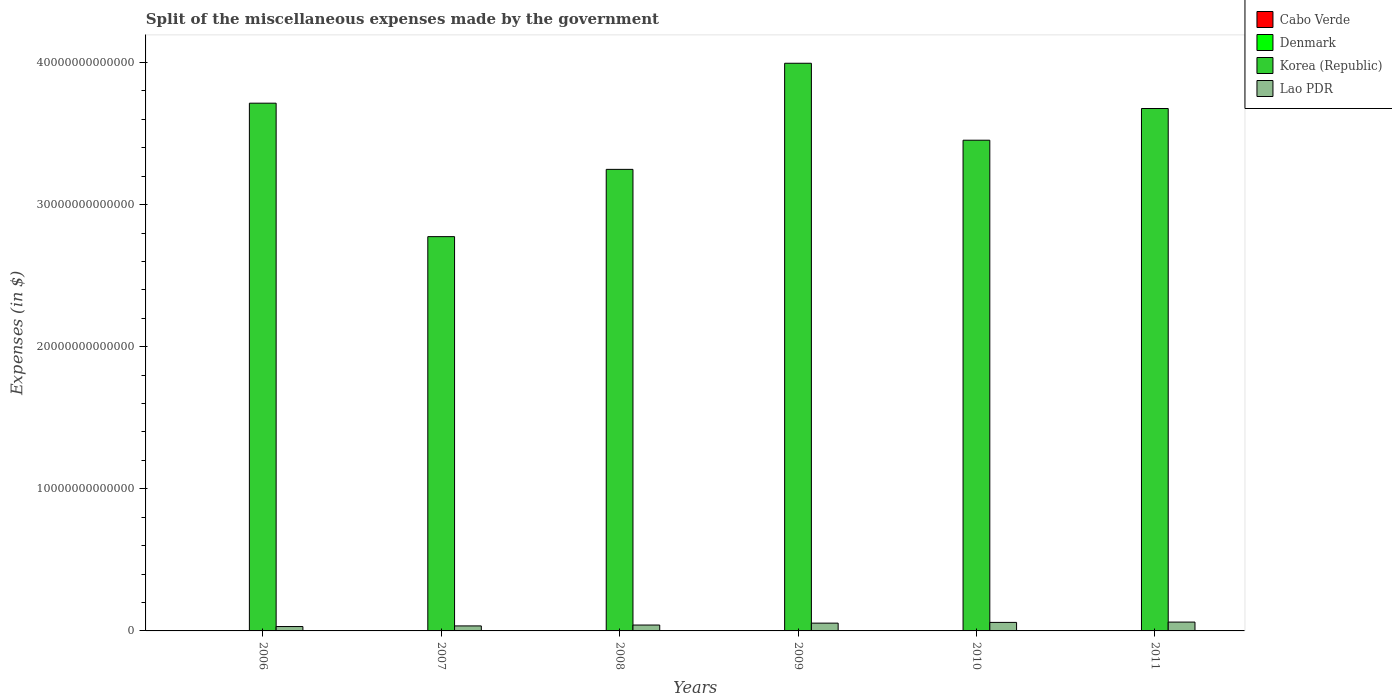How many groups of bars are there?
Offer a terse response. 6. How many bars are there on the 2nd tick from the left?
Your response must be concise. 4. How many bars are there on the 2nd tick from the right?
Your answer should be compact. 4. What is the miscellaneous expenses made by the government in Denmark in 2009?
Make the answer very short. 1.47e+1. Across all years, what is the maximum miscellaneous expenses made by the government in Korea (Republic)?
Your response must be concise. 3.99e+13. Across all years, what is the minimum miscellaneous expenses made by the government in Korea (Republic)?
Provide a succinct answer. 2.77e+13. In which year was the miscellaneous expenses made by the government in Denmark maximum?
Provide a succinct answer. 2007. In which year was the miscellaneous expenses made by the government in Denmark minimum?
Give a very brief answer. 2006. What is the total miscellaneous expenses made by the government in Korea (Republic) in the graph?
Your answer should be very brief. 2.09e+14. What is the difference between the miscellaneous expenses made by the government in Denmark in 2006 and that in 2009?
Offer a terse response. -1.11e+09. What is the difference between the miscellaneous expenses made by the government in Denmark in 2010 and the miscellaneous expenses made by the government in Korea (Republic) in 2006?
Your answer should be very brief. -3.71e+13. What is the average miscellaneous expenses made by the government in Lao PDR per year?
Your response must be concise. 4.74e+11. In the year 2011, what is the difference between the miscellaneous expenses made by the government in Denmark and miscellaneous expenses made by the government in Korea (Republic)?
Provide a succinct answer. -3.67e+13. What is the ratio of the miscellaneous expenses made by the government in Lao PDR in 2007 to that in 2008?
Keep it short and to the point. 0.85. Is the miscellaneous expenses made by the government in Cabo Verde in 2010 less than that in 2011?
Provide a short and direct response. Yes. What is the difference between the highest and the second highest miscellaneous expenses made by the government in Korea (Republic)?
Your response must be concise. 2.81e+12. What is the difference between the highest and the lowest miscellaneous expenses made by the government in Cabo Verde?
Provide a succinct answer. 1.32e+09. In how many years, is the miscellaneous expenses made by the government in Lao PDR greater than the average miscellaneous expenses made by the government in Lao PDR taken over all years?
Ensure brevity in your answer.  3. What does the 2nd bar from the left in 2011 represents?
Provide a succinct answer. Denmark. What does the 1st bar from the right in 2008 represents?
Provide a short and direct response. Lao PDR. How many bars are there?
Provide a succinct answer. 24. How many years are there in the graph?
Your response must be concise. 6. What is the difference between two consecutive major ticks on the Y-axis?
Offer a terse response. 1.00e+13. Are the values on the major ticks of Y-axis written in scientific E-notation?
Ensure brevity in your answer.  No. Does the graph contain any zero values?
Ensure brevity in your answer.  No. How many legend labels are there?
Ensure brevity in your answer.  4. What is the title of the graph?
Provide a short and direct response. Split of the miscellaneous expenses made by the government. What is the label or title of the Y-axis?
Ensure brevity in your answer.  Expenses (in $). What is the Expenses (in $) in Cabo Verde in 2006?
Make the answer very short. 1.05e+09. What is the Expenses (in $) in Denmark in 2006?
Make the answer very short. 1.36e+1. What is the Expenses (in $) in Korea (Republic) in 2006?
Your answer should be very brief. 3.71e+13. What is the Expenses (in $) of Lao PDR in 2006?
Offer a very short reply. 3.09e+11. What is the Expenses (in $) of Cabo Verde in 2007?
Offer a very short reply. 1.88e+09. What is the Expenses (in $) in Denmark in 2007?
Provide a succinct answer. 1.60e+1. What is the Expenses (in $) of Korea (Republic) in 2007?
Give a very brief answer. 2.77e+13. What is the Expenses (in $) in Lao PDR in 2007?
Make the answer very short. 3.52e+11. What is the Expenses (in $) of Cabo Verde in 2008?
Keep it short and to the point. 2.01e+09. What is the Expenses (in $) in Denmark in 2008?
Make the answer very short. 1.51e+1. What is the Expenses (in $) of Korea (Republic) in 2008?
Make the answer very short. 3.25e+13. What is the Expenses (in $) in Lao PDR in 2008?
Your answer should be very brief. 4.14e+11. What is the Expenses (in $) in Cabo Verde in 2009?
Your answer should be very brief. 6.89e+08. What is the Expenses (in $) of Denmark in 2009?
Provide a short and direct response. 1.47e+1. What is the Expenses (in $) in Korea (Republic) in 2009?
Keep it short and to the point. 3.99e+13. What is the Expenses (in $) of Lao PDR in 2009?
Your answer should be very brief. 5.48e+11. What is the Expenses (in $) of Cabo Verde in 2010?
Give a very brief answer. 1.46e+09. What is the Expenses (in $) of Denmark in 2010?
Your response must be concise. 1.55e+1. What is the Expenses (in $) in Korea (Republic) in 2010?
Provide a succinct answer. 3.45e+13. What is the Expenses (in $) of Lao PDR in 2010?
Provide a short and direct response. 6.00e+11. What is the Expenses (in $) in Cabo Verde in 2011?
Keep it short and to the point. 1.80e+09. What is the Expenses (in $) of Denmark in 2011?
Give a very brief answer. 1.57e+1. What is the Expenses (in $) in Korea (Republic) in 2011?
Provide a short and direct response. 3.68e+13. What is the Expenses (in $) in Lao PDR in 2011?
Your answer should be compact. 6.22e+11. Across all years, what is the maximum Expenses (in $) in Cabo Verde?
Provide a succinct answer. 2.01e+09. Across all years, what is the maximum Expenses (in $) of Denmark?
Provide a succinct answer. 1.60e+1. Across all years, what is the maximum Expenses (in $) in Korea (Republic)?
Make the answer very short. 3.99e+13. Across all years, what is the maximum Expenses (in $) of Lao PDR?
Your response must be concise. 6.22e+11. Across all years, what is the minimum Expenses (in $) in Cabo Verde?
Your answer should be very brief. 6.89e+08. Across all years, what is the minimum Expenses (in $) of Denmark?
Offer a terse response. 1.36e+1. Across all years, what is the minimum Expenses (in $) of Korea (Republic)?
Make the answer very short. 2.77e+13. Across all years, what is the minimum Expenses (in $) of Lao PDR?
Provide a short and direct response. 3.09e+11. What is the total Expenses (in $) of Cabo Verde in the graph?
Provide a short and direct response. 8.88e+09. What is the total Expenses (in $) of Denmark in the graph?
Your answer should be very brief. 9.06e+1. What is the total Expenses (in $) in Korea (Republic) in the graph?
Your response must be concise. 2.09e+14. What is the total Expenses (in $) in Lao PDR in the graph?
Keep it short and to the point. 2.85e+12. What is the difference between the Expenses (in $) in Cabo Verde in 2006 and that in 2007?
Provide a short and direct response. -8.30e+08. What is the difference between the Expenses (in $) of Denmark in 2006 and that in 2007?
Keep it short and to the point. -2.40e+09. What is the difference between the Expenses (in $) in Korea (Republic) in 2006 and that in 2007?
Your answer should be compact. 9.39e+12. What is the difference between the Expenses (in $) of Lao PDR in 2006 and that in 2007?
Your answer should be very brief. -4.33e+1. What is the difference between the Expenses (in $) of Cabo Verde in 2006 and that in 2008?
Your answer should be compact. -9.66e+08. What is the difference between the Expenses (in $) of Denmark in 2006 and that in 2008?
Provide a short and direct response. -1.54e+09. What is the difference between the Expenses (in $) of Korea (Republic) in 2006 and that in 2008?
Your answer should be very brief. 4.66e+12. What is the difference between the Expenses (in $) of Lao PDR in 2006 and that in 2008?
Your answer should be compact. -1.05e+11. What is the difference between the Expenses (in $) of Cabo Verde in 2006 and that in 2009?
Your response must be concise. 3.58e+08. What is the difference between the Expenses (in $) in Denmark in 2006 and that in 2009?
Your response must be concise. -1.11e+09. What is the difference between the Expenses (in $) of Korea (Republic) in 2006 and that in 2009?
Offer a very short reply. -2.81e+12. What is the difference between the Expenses (in $) in Lao PDR in 2006 and that in 2009?
Your answer should be very brief. -2.39e+11. What is the difference between the Expenses (in $) in Cabo Verde in 2006 and that in 2010?
Your response must be concise. -4.09e+08. What is the difference between the Expenses (in $) of Denmark in 2006 and that in 2010?
Offer a terse response. -1.90e+09. What is the difference between the Expenses (in $) in Korea (Republic) in 2006 and that in 2010?
Give a very brief answer. 2.61e+12. What is the difference between the Expenses (in $) of Lao PDR in 2006 and that in 2010?
Ensure brevity in your answer.  -2.91e+11. What is the difference between the Expenses (in $) of Cabo Verde in 2006 and that in 2011?
Give a very brief answer. -7.53e+08. What is the difference between the Expenses (in $) in Denmark in 2006 and that in 2011?
Offer a terse response. -2.07e+09. What is the difference between the Expenses (in $) in Korea (Republic) in 2006 and that in 2011?
Ensure brevity in your answer.  3.75e+11. What is the difference between the Expenses (in $) in Lao PDR in 2006 and that in 2011?
Your answer should be compact. -3.13e+11. What is the difference between the Expenses (in $) of Cabo Verde in 2007 and that in 2008?
Give a very brief answer. -1.36e+08. What is the difference between the Expenses (in $) in Denmark in 2007 and that in 2008?
Provide a succinct answer. 8.52e+08. What is the difference between the Expenses (in $) of Korea (Republic) in 2007 and that in 2008?
Your answer should be compact. -4.73e+12. What is the difference between the Expenses (in $) of Lao PDR in 2007 and that in 2008?
Make the answer very short. -6.17e+1. What is the difference between the Expenses (in $) in Cabo Verde in 2007 and that in 2009?
Ensure brevity in your answer.  1.19e+09. What is the difference between the Expenses (in $) of Denmark in 2007 and that in 2009?
Provide a short and direct response. 1.28e+09. What is the difference between the Expenses (in $) in Korea (Republic) in 2007 and that in 2009?
Your answer should be very brief. -1.22e+13. What is the difference between the Expenses (in $) of Lao PDR in 2007 and that in 2009?
Keep it short and to the point. -1.96e+11. What is the difference between the Expenses (in $) in Cabo Verde in 2007 and that in 2010?
Your answer should be very brief. 4.22e+08. What is the difference between the Expenses (in $) in Denmark in 2007 and that in 2010?
Ensure brevity in your answer.  4.92e+08. What is the difference between the Expenses (in $) of Korea (Republic) in 2007 and that in 2010?
Your answer should be compact. -6.79e+12. What is the difference between the Expenses (in $) in Lao PDR in 2007 and that in 2010?
Ensure brevity in your answer.  -2.48e+11. What is the difference between the Expenses (in $) in Cabo Verde in 2007 and that in 2011?
Give a very brief answer. 7.77e+07. What is the difference between the Expenses (in $) in Denmark in 2007 and that in 2011?
Make the answer very short. 3.27e+08. What is the difference between the Expenses (in $) in Korea (Republic) in 2007 and that in 2011?
Your response must be concise. -9.02e+12. What is the difference between the Expenses (in $) in Lao PDR in 2007 and that in 2011?
Give a very brief answer. -2.70e+11. What is the difference between the Expenses (in $) of Cabo Verde in 2008 and that in 2009?
Your response must be concise. 1.32e+09. What is the difference between the Expenses (in $) of Denmark in 2008 and that in 2009?
Offer a very short reply. 4.30e+08. What is the difference between the Expenses (in $) in Korea (Republic) in 2008 and that in 2009?
Provide a succinct answer. -7.47e+12. What is the difference between the Expenses (in $) of Lao PDR in 2008 and that in 2009?
Your response must be concise. -1.34e+11. What is the difference between the Expenses (in $) of Cabo Verde in 2008 and that in 2010?
Your response must be concise. 5.58e+08. What is the difference between the Expenses (in $) in Denmark in 2008 and that in 2010?
Make the answer very short. -3.60e+08. What is the difference between the Expenses (in $) in Korea (Republic) in 2008 and that in 2010?
Offer a very short reply. -2.05e+12. What is the difference between the Expenses (in $) in Lao PDR in 2008 and that in 2010?
Make the answer very short. -1.86e+11. What is the difference between the Expenses (in $) in Cabo Verde in 2008 and that in 2011?
Offer a terse response. 2.14e+08. What is the difference between the Expenses (in $) in Denmark in 2008 and that in 2011?
Offer a very short reply. -5.25e+08. What is the difference between the Expenses (in $) of Korea (Republic) in 2008 and that in 2011?
Ensure brevity in your answer.  -4.28e+12. What is the difference between the Expenses (in $) in Lao PDR in 2008 and that in 2011?
Your answer should be compact. -2.08e+11. What is the difference between the Expenses (in $) of Cabo Verde in 2009 and that in 2010?
Your response must be concise. -7.67e+08. What is the difference between the Expenses (in $) in Denmark in 2009 and that in 2010?
Offer a terse response. -7.90e+08. What is the difference between the Expenses (in $) of Korea (Republic) in 2009 and that in 2010?
Give a very brief answer. 5.41e+12. What is the difference between the Expenses (in $) in Lao PDR in 2009 and that in 2010?
Your answer should be compact. -5.21e+1. What is the difference between the Expenses (in $) in Cabo Verde in 2009 and that in 2011?
Ensure brevity in your answer.  -1.11e+09. What is the difference between the Expenses (in $) of Denmark in 2009 and that in 2011?
Provide a succinct answer. -9.55e+08. What is the difference between the Expenses (in $) in Korea (Republic) in 2009 and that in 2011?
Your answer should be very brief. 3.18e+12. What is the difference between the Expenses (in $) of Lao PDR in 2009 and that in 2011?
Your response must be concise. -7.41e+1. What is the difference between the Expenses (in $) in Cabo Verde in 2010 and that in 2011?
Your response must be concise. -3.44e+08. What is the difference between the Expenses (in $) in Denmark in 2010 and that in 2011?
Your answer should be very brief. -1.65e+08. What is the difference between the Expenses (in $) in Korea (Republic) in 2010 and that in 2011?
Your answer should be very brief. -2.23e+12. What is the difference between the Expenses (in $) in Lao PDR in 2010 and that in 2011?
Your response must be concise. -2.19e+1. What is the difference between the Expenses (in $) of Cabo Verde in 2006 and the Expenses (in $) of Denmark in 2007?
Your answer should be compact. -1.49e+1. What is the difference between the Expenses (in $) in Cabo Verde in 2006 and the Expenses (in $) in Korea (Republic) in 2007?
Provide a succinct answer. -2.77e+13. What is the difference between the Expenses (in $) of Cabo Verde in 2006 and the Expenses (in $) of Lao PDR in 2007?
Provide a succinct answer. -3.51e+11. What is the difference between the Expenses (in $) of Denmark in 2006 and the Expenses (in $) of Korea (Republic) in 2007?
Offer a terse response. -2.77e+13. What is the difference between the Expenses (in $) of Denmark in 2006 and the Expenses (in $) of Lao PDR in 2007?
Offer a terse response. -3.39e+11. What is the difference between the Expenses (in $) in Korea (Republic) in 2006 and the Expenses (in $) in Lao PDR in 2007?
Offer a terse response. 3.68e+13. What is the difference between the Expenses (in $) of Cabo Verde in 2006 and the Expenses (in $) of Denmark in 2008?
Offer a terse response. -1.41e+1. What is the difference between the Expenses (in $) of Cabo Verde in 2006 and the Expenses (in $) of Korea (Republic) in 2008?
Ensure brevity in your answer.  -3.25e+13. What is the difference between the Expenses (in $) in Cabo Verde in 2006 and the Expenses (in $) in Lao PDR in 2008?
Provide a short and direct response. -4.13e+11. What is the difference between the Expenses (in $) in Denmark in 2006 and the Expenses (in $) in Korea (Republic) in 2008?
Your response must be concise. -3.25e+13. What is the difference between the Expenses (in $) of Denmark in 2006 and the Expenses (in $) of Lao PDR in 2008?
Provide a succinct answer. -4.00e+11. What is the difference between the Expenses (in $) in Korea (Republic) in 2006 and the Expenses (in $) in Lao PDR in 2008?
Provide a succinct answer. 3.67e+13. What is the difference between the Expenses (in $) in Cabo Verde in 2006 and the Expenses (in $) in Denmark in 2009?
Offer a terse response. -1.37e+1. What is the difference between the Expenses (in $) in Cabo Verde in 2006 and the Expenses (in $) in Korea (Republic) in 2009?
Your response must be concise. -3.99e+13. What is the difference between the Expenses (in $) in Cabo Verde in 2006 and the Expenses (in $) in Lao PDR in 2009?
Ensure brevity in your answer.  -5.47e+11. What is the difference between the Expenses (in $) of Denmark in 2006 and the Expenses (in $) of Korea (Republic) in 2009?
Ensure brevity in your answer.  -3.99e+13. What is the difference between the Expenses (in $) of Denmark in 2006 and the Expenses (in $) of Lao PDR in 2009?
Provide a short and direct response. -5.34e+11. What is the difference between the Expenses (in $) in Korea (Republic) in 2006 and the Expenses (in $) in Lao PDR in 2009?
Your answer should be very brief. 3.66e+13. What is the difference between the Expenses (in $) in Cabo Verde in 2006 and the Expenses (in $) in Denmark in 2010?
Give a very brief answer. -1.45e+1. What is the difference between the Expenses (in $) in Cabo Verde in 2006 and the Expenses (in $) in Korea (Republic) in 2010?
Offer a terse response. -3.45e+13. What is the difference between the Expenses (in $) of Cabo Verde in 2006 and the Expenses (in $) of Lao PDR in 2010?
Offer a very short reply. -5.99e+11. What is the difference between the Expenses (in $) of Denmark in 2006 and the Expenses (in $) of Korea (Republic) in 2010?
Give a very brief answer. -3.45e+13. What is the difference between the Expenses (in $) of Denmark in 2006 and the Expenses (in $) of Lao PDR in 2010?
Keep it short and to the point. -5.87e+11. What is the difference between the Expenses (in $) in Korea (Republic) in 2006 and the Expenses (in $) in Lao PDR in 2010?
Ensure brevity in your answer.  3.65e+13. What is the difference between the Expenses (in $) in Cabo Verde in 2006 and the Expenses (in $) in Denmark in 2011?
Offer a terse response. -1.46e+1. What is the difference between the Expenses (in $) in Cabo Verde in 2006 and the Expenses (in $) in Korea (Republic) in 2011?
Ensure brevity in your answer.  -3.68e+13. What is the difference between the Expenses (in $) in Cabo Verde in 2006 and the Expenses (in $) in Lao PDR in 2011?
Your response must be concise. -6.21e+11. What is the difference between the Expenses (in $) of Denmark in 2006 and the Expenses (in $) of Korea (Republic) in 2011?
Keep it short and to the point. -3.67e+13. What is the difference between the Expenses (in $) in Denmark in 2006 and the Expenses (in $) in Lao PDR in 2011?
Offer a very short reply. -6.09e+11. What is the difference between the Expenses (in $) of Korea (Republic) in 2006 and the Expenses (in $) of Lao PDR in 2011?
Your answer should be compact. 3.65e+13. What is the difference between the Expenses (in $) in Cabo Verde in 2007 and the Expenses (in $) in Denmark in 2008?
Keep it short and to the point. -1.33e+1. What is the difference between the Expenses (in $) of Cabo Verde in 2007 and the Expenses (in $) of Korea (Republic) in 2008?
Offer a terse response. -3.25e+13. What is the difference between the Expenses (in $) in Cabo Verde in 2007 and the Expenses (in $) in Lao PDR in 2008?
Keep it short and to the point. -4.12e+11. What is the difference between the Expenses (in $) in Denmark in 2007 and the Expenses (in $) in Korea (Republic) in 2008?
Make the answer very short. -3.25e+13. What is the difference between the Expenses (in $) of Denmark in 2007 and the Expenses (in $) of Lao PDR in 2008?
Ensure brevity in your answer.  -3.98e+11. What is the difference between the Expenses (in $) in Korea (Republic) in 2007 and the Expenses (in $) in Lao PDR in 2008?
Ensure brevity in your answer.  2.73e+13. What is the difference between the Expenses (in $) in Cabo Verde in 2007 and the Expenses (in $) in Denmark in 2009?
Provide a succinct answer. -1.28e+1. What is the difference between the Expenses (in $) of Cabo Verde in 2007 and the Expenses (in $) of Korea (Republic) in 2009?
Offer a very short reply. -3.99e+13. What is the difference between the Expenses (in $) in Cabo Verde in 2007 and the Expenses (in $) in Lao PDR in 2009?
Provide a succinct answer. -5.46e+11. What is the difference between the Expenses (in $) in Denmark in 2007 and the Expenses (in $) in Korea (Republic) in 2009?
Offer a terse response. -3.99e+13. What is the difference between the Expenses (in $) in Denmark in 2007 and the Expenses (in $) in Lao PDR in 2009?
Provide a short and direct response. -5.32e+11. What is the difference between the Expenses (in $) of Korea (Republic) in 2007 and the Expenses (in $) of Lao PDR in 2009?
Make the answer very short. 2.72e+13. What is the difference between the Expenses (in $) in Cabo Verde in 2007 and the Expenses (in $) in Denmark in 2010?
Offer a very short reply. -1.36e+1. What is the difference between the Expenses (in $) in Cabo Verde in 2007 and the Expenses (in $) in Korea (Republic) in 2010?
Your response must be concise. -3.45e+13. What is the difference between the Expenses (in $) of Cabo Verde in 2007 and the Expenses (in $) of Lao PDR in 2010?
Your answer should be very brief. -5.98e+11. What is the difference between the Expenses (in $) in Denmark in 2007 and the Expenses (in $) in Korea (Republic) in 2010?
Your answer should be very brief. -3.45e+13. What is the difference between the Expenses (in $) of Denmark in 2007 and the Expenses (in $) of Lao PDR in 2010?
Keep it short and to the point. -5.84e+11. What is the difference between the Expenses (in $) of Korea (Republic) in 2007 and the Expenses (in $) of Lao PDR in 2010?
Provide a succinct answer. 2.71e+13. What is the difference between the Expenses (in $) of Cabo Verde in 2007 and the Expenses (in $) of Denmark in 2011?
Your answer should be compact. -1.38e+1. What is the difference between the Expenses (in $) of Cabo Verde in 2007 and the Expenses (in $) of Korea (Republic) in 2011?
Provide a short and direct response. -3.68e+13. What is the difference between the Expenses (in $) of Cabo Verde in 2007 and the Expenses (in $) of Lao PDR in 2011?
Provide a succinct answer. -6.20e+11. What is the difference between the Expenses (in $) in Denmark in 2007 and the Expenses (in $) in Korea (Republic) in 2011?
Give a very brief answer. -3.67e+13. What is the difference between the Expenses (in $) of Denmark in 2007 and the Expenses (in $) of Lao PDR in 2011?
Your response must be concise. -6.06e+11. What is the difference between the Expenses (in $) of Korea (Republic) in 2007 and the Expenses (in $) of Lao PDR in 2011?
Give a very brief answer. 2.71e+13. What is the difference between the Expenses (in $) of Cabo Verde in 2008 and the Expenses (in $) of Denmark in 2009?
Ensure brevity in your answer.  -1.27e+1. What is the difference between the Expenses (in $) in Cabo Verde in 2008 and the Expenses (in $) in Korea (Republic) in 2009?
Your response must be concise. -3.99e+13. What is the difference between the Expenses (in $) in Cabo Verde in 2008 and the Expenses (in $) in Lao PDR in 2009?
Your answer should be compact. -5.46e+11. What is the difference between the Expenses (in $) of Denmark in 2008 and the Expenses (in $) of Korea (Republic) in 2009?
Provide a succinct answer. -3.99e+13. What is the difference between the Expenses (in $) in Denmark in 2008 and the Expenses (in $) in Lao PDR in 2009?
Your response must be concise. -5.33e+11. What is the difference between the Expenses (in $) of Korea (Republic) in 2008 and the Expenses (in $) of Lao PDR in 2009?
Your answer should be very brief. 3.19e+13. What is the difference between the Expenses (in $) in Cabo Verde in 2008 and the Expenses (in $) in Denmark in 2010?
Your answer should be very brief. -1.35e+1. What is the difference between the Expenses (in $) in Cabo Verde in 2008 and the Expenses (in $) in Korea (Republic) in 2010?
Keep it short and to the point. -3.45e+13. What is the difference between the Expenses (in $) of Cabo Verde in 2008 and the Expenses (in $) of Lao PDR in 2010?
Your answer should be compact. -5.98e+11. What is the difference between the Expenses (in $) in Denmark in 2008 and the Expenses (in $) in Korea (Republic) in 2010?
Give a very brief answer. -3.45e+13. What is the difference between the Expenses (in $) in Denmark in 2008 and the Expenses (in $) in Lao PDR in 2010?
Provide a succinct answer. -5.85e+11. What is the difference between the Expenses (in $) of Korea (Republic) in 2008 and the Expenses (in $) of Lao PDR in 2010?
Provide a short and direct response. 3.19e+13. What is the difference between the Expenses (in $) in Cabo Verde in 2008 and the Expenses (in $) in Denmark in 2011?
Give a very brief answer. -1.37e+1. What is the difference between the Expenses (in $) of Cabo Verde in 2008 and the Expenses (in $) of Korea (Republic) in 2011?
Make the answer very short. -3.68e+13. What is the difference between the Expenses (in $) of Cabo Verde in 2008 and the Expenses (in $) of Lao PDR in 2011?
Your response must be concise. -6.20e+11. What is the difference between the Expenses (in $) in Denmark in 2008 and the Expenses (in $) in Korea (Republic) in 2011?
Provide a short and direct response. -3.67e+13. What is the difference between the Expenses (in $) of Denmark in 2008 and the Expenses (in $) of Lao PDR in 2011?
Your response must be concise. -6.07e+11. What is the difference between the Expenses (in $) in Korea (Republic) in 2008 and the Expenses (in $) in Lao PDR in 2011?
Give a very brief answer. 3.19e+13. What is the difference between the Expenses (in $) of Cabo Verde in 2009 and the Expenses (in $) of Denmark in 2010?
Your response must be concise. -1.48e+1. What is the difference between the Expenses (in $) in Cabo Verde in 2009 and the Expenses (in $) in Korea (Republic) in 2010?
Give a very brief answer. -3.45e+13. What is the difference between the Expenses (in $) in Cabo Verde in 2009 and the Expenses (in $) in Lao PDR in 2010?
Your answer should be compact. -6.00e+11. What is the difference between the Expenses (in $) of Denmark in 2009 and the Expenses (in $) of Korea (Republic) in 2010?
Keep it short and to the point. -3.45e+13. What is the difference between the Expenses (in $) in Denmark in 2009 and the Expenses (in $) in Lao PDR in 2010?
Provide a short and direct response. -5.85e+11. What is the difference between the Expenses (in $) of Korea (Republic) in 2009 and the Expenses (in $) of Lao PDR in 2010?
Provide a short and direct response. 3.93e+13. What is the difference between the Expenses (in $) of Cabo Verde in 2009 and the Expenses (in $) of Denmark in 2011?
Offer a very short reply. -1.50e+1. What is the difference between the Expenses (in $) of Cabo Verde in 2009 and the Expenses (in $) of Korea (Republic) in 2011?
Your response must be concise. -3.68e+13. What is the difference between the Expenses (in $) of Cabo Verde in 2009 and the Expenses (in $) of Lao PDR in 2011?
Give a very brief answer. -6.21e+11. What is the difference between the Expenses (in $) in Denmark in 2009 and the Expenses (in $) in Korea (Republic) in 2011?
Ensure brevity in your answer.  -3.67e+13. What is the difference between the Expenses (in $) of Denmark in 2009 and the Expenses (in $) of Lao PDR in 2011?
Provide a short and direct response. -6.07e+11. What is the difference between the Expenses (in $) in Korea (Republic) in 2009 and the Expenses (in $) in Lao PDR in 2011?
Offer a very short reply. 3.93e+13. What is the difference between the Expenses (in $) in Cabo Verde in 2010 and the Expenses (in $) in Denmark in 2011?
Make the answer very short. -1.42e+1. What is the difference between the Expenses (in $) in Cabo Verde in 2010 and the Expenses (in $) in Korea (Republic) in 2011?
Offer a very short reply. -3.68e+13. What is the difference between the Expenses (in $) in Cabo Verde in 2010 and the Expenses (in $) in Lao PDR in 2011?
Ensure brevity in your answer.  -6.21e+11. What is the difference between the Expenses (in $) in Denmark in 2010 and the Expenses (in $) in Korea (Republic) in 2011?
Give a very brief answer. -3.67e+13. What is the difference between the Expenses (in $) of Denmark in 2010 and the Expenses (in $) of Lao PDR in 2011?
Your answer should be very brief. -6.07e+11. What is the difference between the Expenses (in $) of Korea (Republic) in 2010 and the Expenses (in $) of Lao PDR in 2011?
Your answer should be very brief. 3.39e+13. What is the average Expenses (in $) of Cabo Verde per year?
Keep it short and to the point. 1.48e+09. What is the average Expenses (in $) of Denmark per year?
Your answer should be very brief. 1.51e+1. What is the average Expenses (in $) in Korea (Republic) per year?
Provide a succinct answer. 3.48e+13. What is the average Expenses (in $) of Lao PDR per year?
Make the answer very short. 4.74e+11. In the year 2006, what is the difference between the Expenses (in $) of Cabo Verde and Expenses (in $) of Denmark?
Your answer should be very brief. -1.25e+1. In the year 2006, what is the difference between the Expenses (in $) in Cabo Verde and Expenses (in $) in Korea (Republic)?
Offer a very short reply. -3.71e+13. In the year 2006, what is the difference between the Expenses (in $) of Cabo Verde and Expenses (in $) of Lao PDR?
Keep it short and to the point. -3.08e+11. In the year 2006, what is the difference between the Expenses (in $) in Denmark and Expenses (in $) in Korea (Republic)?
Offer a terse response. -3.71e+13. In the year 2006, what is the difference between the Expenses (in $) of Denmark and Expenses (in $) of Lao PDR?
Make the answer very short. -2.95e+11. In the year 2006, what is the difference between the Expenses (in $) of Korea (Republic) and Expenses (in $) of Lao PDR?
Your response must be concise. 3.68e+13. In the year 2007, what is the difference between the Expenses (in $) of Cabo Verde and Expenses (in $) of Denmark?
Give a very brief answer. -1.41e+1. In the year 2007, what is the difference between the Expenses (in $) of Cabo Verde and Expenses (in $) of Korea (Republic)?
Your answer should be compact. -2.77e+13. In the year 2007, what is the difference between the Expenses (in $) in Cabo Verde and Expenses (in $) in Lao PDR?
Make the answer very short. -3.50e+11. In the year 2007, what is the difference between the Expenses (in $) in Denmark and Expenses (in $) in Korea (Republic)?
Provide a short and direct response. -2.77e+13. In the year 2007, what is the difference between the Expenses (in $) of Denmark and Expenses (in $) of Lao PDR?
Keep it short and to the point. -3.36e+11. In the year 2007, what is the difference between the Expenses (in $) of Korea (Republic) and Expenses (in $) of Lao PDR?
Your answer should be very brief. 2.74e+13. In the year 2008, what is the difference between the Expenses (in $) of Cabo Verde and Expenses (in $) of Denmark?
Offer a very short reply. -1.31e+1. In the year 2008, what is the difference between the Expenses (in $) in Cabo Verde and Expenses (in $) in Korea (Republic)?
Your answer should be very brief. -3.25e+13. In the year 2008, what is the difference between the Expenses (in $) of Cabo Verde and Expenses (in $) of Lao PDR?
Offer a very short reply. -4.12e+11. In the year 2008, what is the difference between the Expenses (in $) in Denmark and Expenses (in $) in Korea (Republic)?
Your response must be concise. -3.25e+13. In the year 2008, what is the difference between the Expenses (in $) in Denmark and Expenses (in $) in Lao PDR?
Provide a short and direct response. -3.99e+11. In the year 2008, what is the difference between the Expenses (in $) in Korea (Republic) and Expenses (in $) in Lao PDR?
Your answer should be very brief. 3.21e+13. In the year 2009, what is the difference between the Expenses (in $) of Cabo Verde and Expenses (in $) of Denmark?
Give a very brief answer. -1.40e+1. In the year 2009, what is the difference between the Expenses (in $) of Cabo Verde and Expenses (in $) of Korea (Republic)?
Offer a very short reply. -3.99e+13. In the year 2009, what is the difference between the Expenses (in $) of Cabo Verde and Expenses (in $) of Lao PDR?
Provide a short and direct response. -5.47e+11. In the year 2009, what is the difference between the Expenses (in $) of Denmark and Expenses (in $) of Korea (Republic)?
Provide a succinct answer. -3.99e+13. In the year 2009, what is the difference between the Expenses (in $) in Denmark and Expenses (in $) in Lao PDR?
Your answer should be very brief. -5.33e+11. In the year 2009, what is the difference between the Expenses (in $) in Korea (Republic) and Expenses (in $) in Lao PDR?
Your answer should be compact. 3.94e+13. In the year 2010, what is the difference between the Expenses (in $) of Cabo Verde and Expenses (in $) of Denmark?
Keep it short and to the point. -1.40e+1. In the year 2010, what is the difference between the Expenses (in $) in Cabo Verde and Expenses (in $) in Korea (Republic)?
Offer a terse response. -3.45e+13. In the year 2010, what is the difference between the Expenses (in $) of Cabo Verde and Expenses (in $) of Lao PDR?
Offer a very short reply. -5.99e+11. In the year 2010, what is the difference between the Expenses (in $) in Denmark and Expenses (in $) in Korea (Republic)?
Provide a short and direct response. -3.45e+13. In the year 2010, what is the difference between the Expenses (in $) of Denmark and Expenses (in $) of Lao PDR?
Your answer should be compact. -5.85e+11. In the year 2010, what is the difference between the Expenses (in $) in Korea (Republic) and Expenses (in $) in Lao PDR?
Offer a terse response. 3.39e+13. In the year 2011, what is the difference between the Expenses (in $) in Cabo Verde and Expenses (in $) in Denmark?
Provide a short and direct response. -1.39e+1. In the year 2011, what is the difference between the Expenses (in $) of Cabo Verde and Expenses (in $) of Korea (Republic)?
Keep it short and to the point. -3.68e+13. In the year 2011, what is the difference between the Expenses (in $) of Cabo Verde and Expenses (in $) of Lao PDR?
Provide a succinct answer. -6.20e+11. In the year 2011, what is the difference between the Expenses (in $) of Denmark and Expenses (in $) of Korea (Republic)?
Your answer should be very brief. -3.67e+13. In the year 2011, what is the difference between the Expenses (in $) of Denmark and Expenses (in $) of Lao PDR?
Make the answer very short. -6.06e+11. In the year 2011, what is the difference between the Expenses (in $) in Korea (Republic) and Expenses (in $) in Lao PDR?
Your response must be concise. 3.61e+13. What is the ratio of the Expenses (in $) of Cabo Verde in 2006 to that in 2007?
Offer a terse response. 0.56. What is the ratio of the Expenses (in $) in Denmark in 2006 to that in 2007?
Give a very brief answer. 0.85. What is the ratio of the Expenses (in $) in Korea (Republic) in 2006 to that in 2007?
Offer a terse response. 1.34. What is the ratio of the Expenses (in $) of Lao PDR in 2006 to that in 2007?
Ensure brevity in your answer.  0.88. What is the ratio of the Expenses (in $) in Cabo Verde in 2006 to that in 2008?
Offer a very short reply. 0.52. What is the ratio of the Expenses (in $) in Denmark in 2006 to that in 2008?
Provide a succinct answer. 0.9. What is the ratio of the Expenses (in $) in Korea (Republic) in 2006 to that in 2008?
Your answer should be compact. 1.14. What is the ratio of the Expenses (in $) of Lao PDR in 2006 to that in 2008?
Make the answer very short. 0.75. What is the ratio of the Expenses (in $) of Cabo Verde in 2006 to that in 2009?
Your response must be concise. 1.52. What is the ratio of the Expenses (in $) of Denmark in 2006 to that in 2009?
Offer a terse response. 0.92. What is the ratio of the Expenses (in $) in Korea (Republic) in 2006 to that in 2009?
Give a very brief answer. 0.93. What is the ratio of the Expenses (in $) in Lao PDR in 2006 to that in 2009?
Your response must be concise. 0.56. What is the ratio of the Expenses (in $) in Cabo Verde in 2006 to that in 2010?
Provide a short and direct response. 0.72. What is the ratio of the Expenses (in $) of Denmark in 2006 to that in 2010?
Ensure brevity in your answer.  0.88. What is the ratio of the Expenses (in $) in Korea (Republic) in 2006 to that in 2010?
Offer a terse response. 1.08. What is the ratio of the Expenses (in $) in Lao PDR in 2006 to that in 2010?
Provide a succinct answer. 0.51. What is the ratio of the Expenses (in $) in Cabo Verde in 2006 to that in 2011?
Provide a succinct answer. 0.58. What is the ratio of the Expenses (in $) of Denmark in 2006 to that in 2011?
Your response must be concise. 0.87. What is the ratio of the Expenses (in $) of Korea (Republic) in 2006 to that in 2011?
Give a very brief answer. 1.01. What is the ratio of the Expenses (in $) in Lao PDR in 2006 to that in 2011?
Provide a short and direct response. 0.5. What is the ratio of the Expenses (in $) of Cabo Verde in 2007 to that in 2008?
Your answer should be compact. 0.93. What is the ratio of the Expenses (in $) in Denmark in 2007 to that in 2008?
Your answer should be very brief. 1.06. What is the ratio of the Expenses (in $) of Korea (Republic) in 2007 to that in 2008?
Your answer should be compact. 0.85. What is the ratio of the Expenses (in $) in Lao PDR in 2007 to that in 2008?
Provide a short and direct response. 0.85. What is the ratio of the Expenses (in $) in Cabo Verde in 2007 to that in 2009?
Make the answer very short. 2.72. What is the ratio of the Expenses (in $) in Denmark in 2007 to that in 2009?
Give a very brief answer. 1.09. What is the ratio of the Expenses (in $) in Korea (Republic) in 2007 to that in 2009?
Your response must be concise. 0.69. What is the ratio of the Expenses (in $) of Lao PDR in 2007 to that in 2009?
Offer a very short reply. 0.64. What is the ratio of the Expenses (in $) of Cabo Verde in 2007 to that in 2010?
Offer a very short reply. 1.29. What is the ratio of the Expenses (in $) of Denmark in 2007 to that in 2010?
Your answer should be very brief. 1.03. What is the ratio of the Expenses (in $) of Korea (Republic) in 2007 to that in 2010?
Make the answer very short. 0.8. What is the ratio of the Expenses (in $) of Lao PDR in 2007 to that in 2010?
Keep it short and to the point. 0.59. What is the ratio of the Expenses (in $) of Cabo Verde in 2007 to that in 2011?
Give a very brief answer. 1.04. What is the ratio of the Expenses (in $) of Denmark in 2007 to that in 2011?
Offer a terse response. 1.02. What is the ratio of the Expenses (in $) in Korea (Republic) in 2007 to that in 2011?
Offer a very short reply. 0.75. What is the ratio of the Expenses (in $) in Lao PDR in 2007 to that in 2011?
Your answer should be very brief. 0.57. What is the ratio of the Expenses (in $) in Cabo Verde in 2008 to that in 2009?
Your answer should be very brief. 2.92. What is the ratio of the Expenses (in $) of Denmark in 2008 to that in 2009?
Give a very brief answer. 1.03. What is the ratio of the Expenses (in $) in Korea (Republic) in 2008 to that in 2009?
Give a very brief answer. 0.81. What is the ratio of the Expenses (in $) in Lao PDR in 2008 to that in 2009?
Provide a short and direct response. 0.76. What is the ratio of the Expenses (in $) in Cabo Verde in 2008 to that in 2010?
Your answer should be very brief. 1.38. What is the ratio of the Expenses (in $) in Denmark in 2008 to that in 2010?
Ensure brevity in your answer.  0.98. What is the ratio of the Expenses (in $) of Korea (Republic) in 2008 to that in 2010?
Provide a short and direct response. 0.94. What is the ratio of the Expenses (in $) of Lao PDR in 2008 to that in 2010?
Keep it short and to the point. 0.69. What is the ratio of the Expenses (in $) of Cabo Verde in 2008 to that in 2011?
Offer a very short reply. 1.12. What is the ratio of the Expenses (in $) in Denmark in 2008 to that in 2011?
Your answer should be very brief. 0.97. What is the ratio of the Expenses (in $) of Korea (Republic) in 2008 to that in 2011?
Offer a very short reply. 0.88. What is the ratio of the Expenses (in $) in Lao PDR in 2008 to that in 2011?
Give a very brief answer. 0.67. What is the ratio of the Expenses (in $) in Cabo Verde in 2009 to that in 2010?
Keep it short and to the point. 0.47. What is the ratio of the Expenses (in $) in Denmark in 2009 to that in 2010?
Your answer should be very brief. 0.95. What is the ratio of the Expenses (in $) of Korea (Republic) in 2009 to that in 2010?
Your answer should be compact. 1.16. What is the ratio of the Expenses (in $) in Lao PDR in 2009 to that in 2010?
Make the answer very short. 0.91. What is the ratio of the Expenses (in $) of Cabo Verde in 2009 to that in 2011?
Provide a short and direct response. 0.38. What is the ratio of the Expenses (in $) of Denmark in 2009 to that in 2011?
Make the answer very short. 0.94. What is the ratio of the Expenses (in $) of Korea (Republic) in 2009 to that in 2011?
Your answer should be compact. 1.09. What is the ratio of the Expenses (in $) of Lao PDR in 2009 to that in 2011?
Provide a short and direct response. 0.88. What is the ratio of the Expenses (in $) of Cabo Verde in 2010 to that in 2011?
Offer a very short reply. 0.81. What is the ratio of the Expenses (in $) in Denmark in 2010 to that in 2011?
Offer a very short reply. 0.99. What is the ratio of the Expenses (in $) in Korea (Republic) in 2010 to that in 2011?
Your answer should be very brief. 0.94. What is the ratio of the Expenses (in $) of Lao PDR in 2010 to that in 2011?
Provide a succinct answer. 0.96. What is the difference between the highest and the second highest Expenses (in $) in Cabo Verde?
Ensure brevity in your answer.  1.36e+08. What is the difference between the highest and the second highest Expenses (in $) in Denmark?
Provide a short and direct response. 3.27e+08. What is the difference between the highest and the second highest Expenses (in $) of Korea (Republic)?
Give a very brief answer. 2.81e+12. What is the difference between the highest and the second highest Expenses (in $) of Lao PDR?
Offer a terse response. 2.19e+1. What is the difference between the highest and the lowest Expenses (in $) in Cabo Verde?
Ensure brevity in your answer.  1.32e+09. What is the difference between the highest and the lowest Expenses (in $) of Denmark?
Your response must be concise. 2.40e+09. What is the difference between the highest and the lowest Expenses (in $) in Korea (Republic)?
Offer a terse response. 1.22e+13. What is the difference between the highest and the lowest Expenses (in $) in Lao PDR?
Provide a short and direct response. 3.13e+11. 